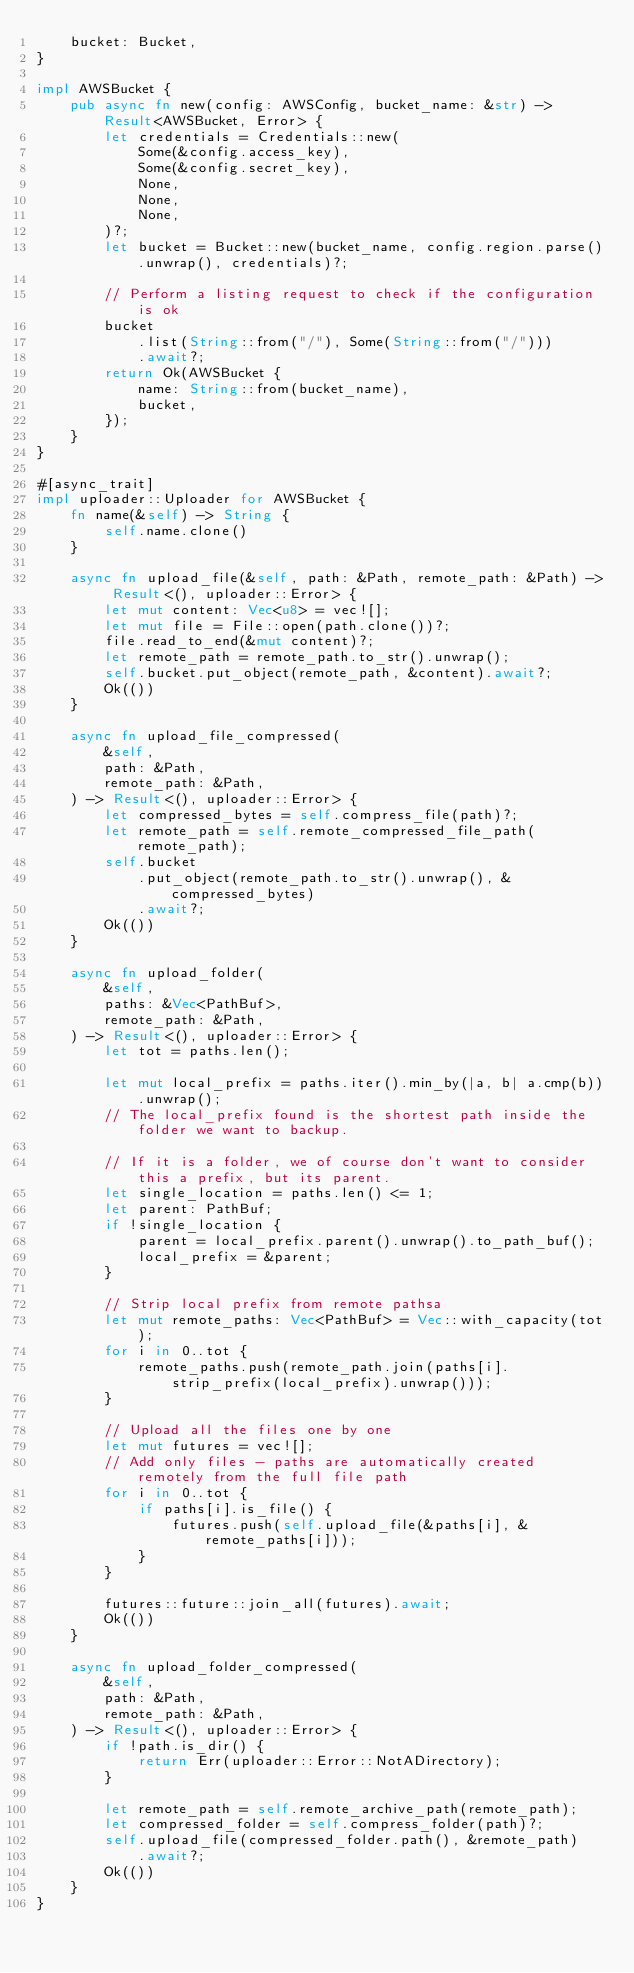Convert code to text. <code><loc_0><loc_0><loc_500><loc_500><_Rust_>    bucket: Bucket,
}

impl AWSBucket {
    pub async fn new(config: AWSConfig, bucket_name: &str) -> Result<AWSBucket, Error> {
        let credentials = Credentials::new(
            Some(&config.access_key),
            Some(&config.secret_key),
            None,
            None,
            None,
        )?;
        let bucket = Bucket::new(bucket_name, config.region.parse().unwrap(), credentials)?;

        // Perform a listing request to check if the configuration is ok
        bucket
            .list(String::from("/"), Some(String::from("/")))
            .await?;
        return Ok(AWSBucket {
            name: String::from(bucket_name),
            bucket,
        });
    }
}

#[async_trait]
impl uploader::Uploader for AWSBucket {
    fn name(&self) -> String {
        self.name.clone()
    }

    async fn upload_file(&self, path: &Path, remote_path: &Path) -> Result<(), uploader::Error> {
        let mut content: Vec<u8> = vec![];
        let mut file = File::open(path.clone())?;
        file.read_to_end(&mut content)?;
        let remote_path = remote_path.to_str().unwrap();
        self.bucket.put_object(remote_path, &content).await?;
        Ok(())
    }

    async fn upload_file_compressed(
        &self,
        path: &Path,
        remote_path: &Path,
    ) -> Result<(), uploader::Error> {
        let compressed_bytes = self.compress_file(path)?;
        let remote_path = self.remote_compressed_file_path(remote_path);
        self.bucket
            .put_object(remote_path.to_str().unwrap(), &compressed_bytes)
            .await?;
        Ok(())
    }

    async fn upload_folder(
        &self,
        paths: &Vec<PathBuf>,
        remote_path: &Path,
    ) -> Result<(), uploader::Error> {
        let tot = paths.len();

        let mut local_prefix = paths.iter().min_by(|a, b| a.cmp(b)).unwrap();
        // The local_prefix found is the shortest path inside the folder we want to backup.

        // If it is a folder, we of course don't want to consider this a prefix, but its parent.
        let single_location = paths.len() <= 1;
        let parent: PathBuf;
        if !single_location {
            parent = local_prefix.parent().unwrap().to_path_buf();
            local_prefix = &parent;
        }

        // Strip local prefix from remote pathsa
        let mut remote_paths: Vec<PathBuf> = Vec::with_capacity(tot);
        for i in 0..tot {
            remote_paths.push(remote_path.join(paths[i].strip_prefix(local_prefix).unwrap()));
        }

        // Upload all the files one by one
        let mut futures = vec![];
        // Add only files - paths are automatically created remotely from the full file path
        for i in 0..tot {
            if paths[i].is_file() {
                futures.push(self.upload_file(&paths[i], &remote_paths[i]));
            }
        }

        futures::future::join_all(futures).await;
        Ok(())
    }

    async fn upload_folder_compressed(
        &self,
        path: &Path,
        remote_path: &Path,
    ) -> Result<(), uploader::Error> {
        if !path.is_dir() {
            return Err(uploader::Error::NotADirectory);
        }

        let remote_path = self.remote_archive_path(remote_path);
        let compressed_folder = self.compress_folder(path)?;
        self.upload_file(compressed_folder.path(), &remote_path)
            .await?;
        Ok(())
    }
}
</code> 